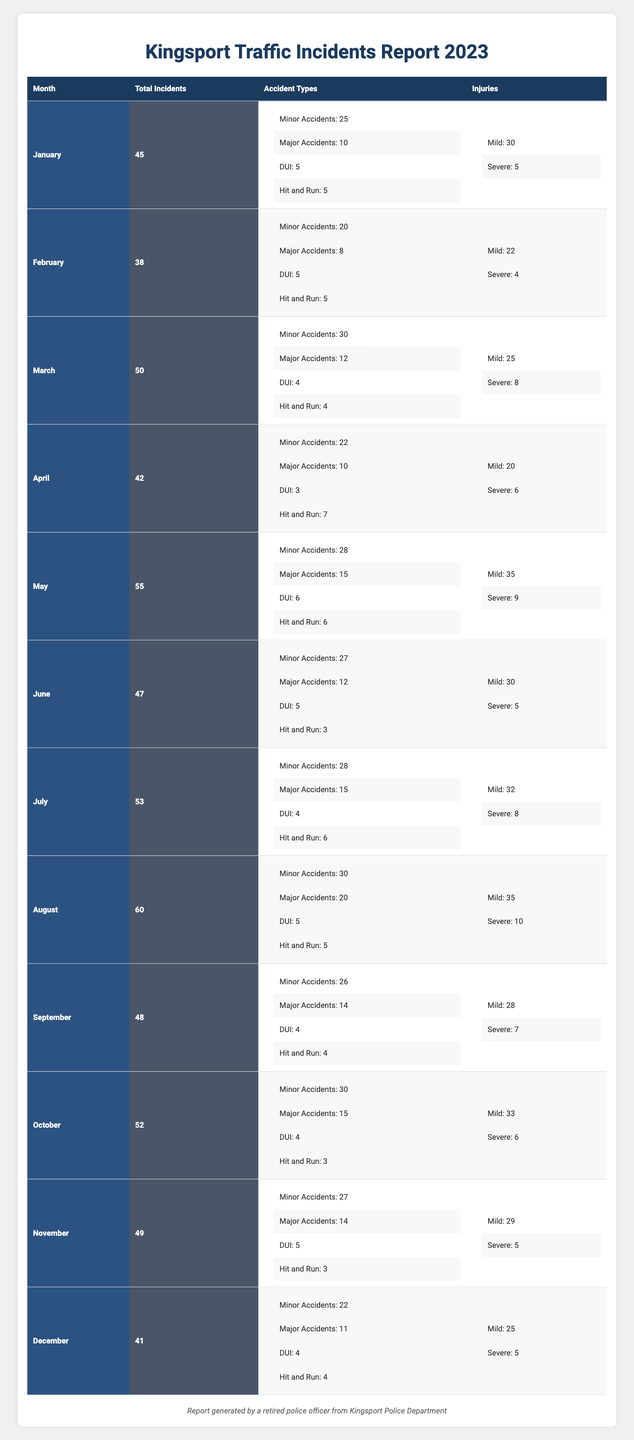What was the total number of traffic incidents in August 2023? In August, the table indicates that the total number of traffic incidents was 60.
Answer: 60 How many DUI incidents were reported in April 2023? According to the table, the number of DUI incidents in April is specified as 3.
Answer: 3 Which month had the highest number of severe injuries? By searching the injury counts for each month, I find that August reported 10 severe injuries, which is the highest among all months.
Answer: 10 What is the total count of minor accidents from January to March? To find the total minor accidents, I add January (25), February (20), and March (30) together: 25 + 20 + 30 = 75.
Answer: 75 In which month did the incidents decrease from the previous month, and what was the total incidents that month? Looking at the total incidents month by month, incidents decreased from 55 in May to 47 in June, meaning June saw a decrease. June's total incidents were 47.
Answer: June, 47 Were there more major accidents in November than in January? For November, the total is 14 major accidents, while January has 10. Since 14 is greater than 10, the answer is yes.
Answer: Yes What was the average number of total traffic incidents from January to April? To find the average, sum the total incidents for each month from January to April (45 + 38 + 50 + 42 = 175) and divide by 4: 175/4 = 43.75.
Answer: 43.75 Compare the total number of incidents in December and February; which month had the higher incident rate? In December, there were 41 total incidents, while in February, there were 38. Therefore, December had a higher incident rate.
Answer: December What was the total number of injuries reported in May 2023? The table shows that in May, there were 35 mild injuries and 9 severe injuries. Adding these gives a total of 35 + 9 = 44 injuries.
Answer: 44 